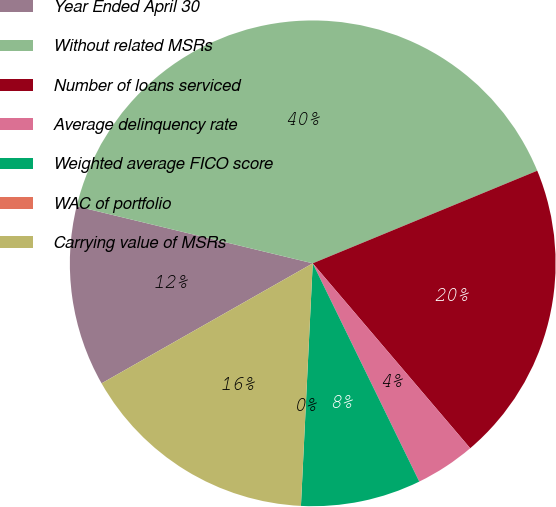Convert chart. <chart><loc_0><loc_0><loc_500><loc_500><pie_chart><fcel>Year Ended April 30<fcel>Without related MSRs<fcel>Number of loans serviced<fcel>Average delinquency rate<fcel>Weighted average FICO score<fcel>WAC of portfolio<fcel>Carrying value of MSRs<nl><fcel>12.0%<fcel>40.0%<fcel>20.0%<fcel>4.0%<fcel>8.0%<fcel>0.0%<fcel>16.0%<nl></chart> 